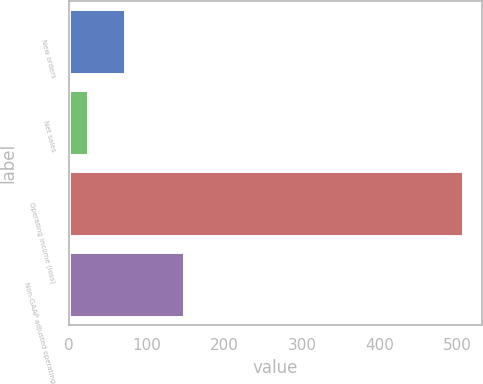Convert chart. <chart><loc_0><loc_0><loc_500><loc_500><bar_chart><fcel>New orders<fcel>Net sales<fcel>Operating income (loss)<fcel>Non-GAAP adjusted operating<nl><fcel>72.3<fcel>24<fcel>507<fcel>148<nl></chart> 